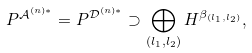<formula> <loc_0><loc_0><loc_500><loc_500>P ^ { \mathcal { A } ^ { ( n ) \ast } } = P ^ { \mathcal { D } ^ { ( n ) \ast } } \supset \bigoplus _ { ( l _ { 1 } , l _ { 2 } ) } H ^ { \beta _ { ( l _ { 1 } , l _ { 2 } ) } } ,</formula> 